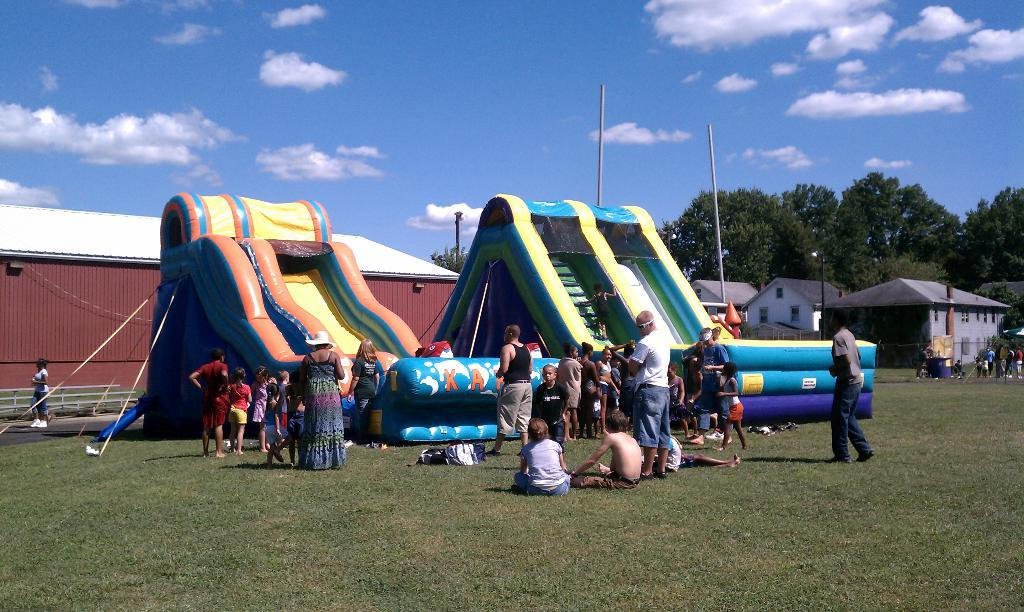What type of objects can be seen in the image? There are inflatables in the image. Are there any people present in the image? Yes, there are people in the image. What type of terrain is visible in the image? Grass is present in the image. What type of structures can be seen in the image? There are houses in the image. What type of vegetation is visible in the image? Trees are visible in the image. What is visible in the sky in the image? The sky is visible in the image, and clouds are present. What type of plate is being used to hold the inflatables in the image? There is no plate present in the image; the inflatables are not being held by a plate. What is the limit of the number of people allowed in the image? There is no limit on the number of people present in the image; the number of people is not restricted. 